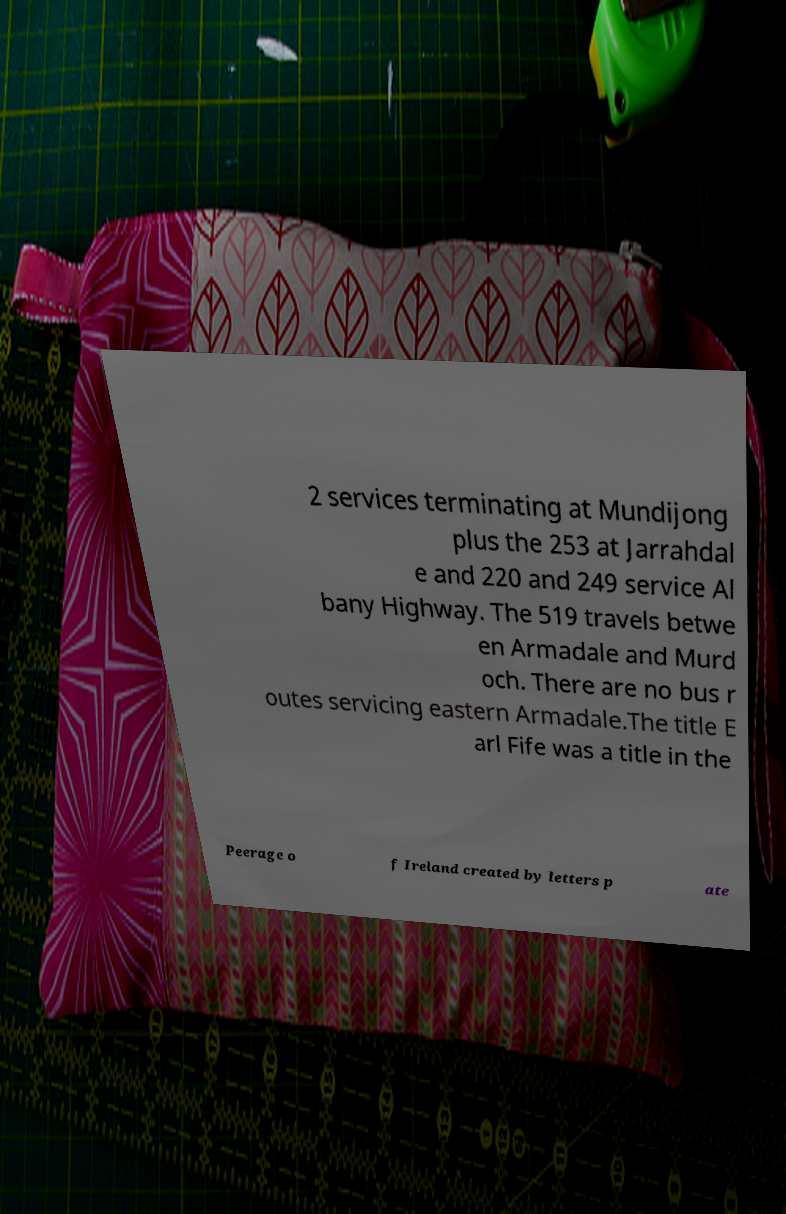For documentation purposes, I need the text within this image transcribed. Could you provide that? 2 services terminating at Mundijong plus the 253 at Jarrahdal e and 220 and 249 service Al bany Highway. The 519 travels betwe en Armadale and Murd och. There are no bus r outes servicing eastern Armadale.The title E arl Fife was a title in the Peerage o f Ireland created by letters p ate 